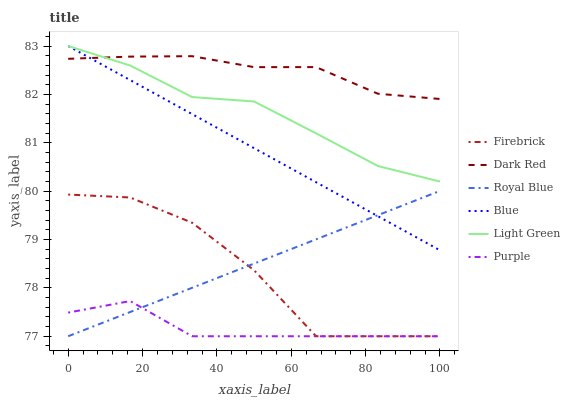Does Dark Red have the minimum area under the curve?
Answer yes or no. No. Does Purple have the maximum area under the curve?
Answer yes or no. No. Is Purple the smoothest?
Answer yes or no. No. Is Purple the roughest?
Answer yes or no. No. Does Dark Red have the lowest value?
Answer yes or no. No. Does Dark Red have the highest value?
Answer yes or no. No. Is Purple less than Dark Red?
Answer yes or no. Yes. Is Dark Red greater than Royal Blue?
Answer yes or no. Yes. Does Purple intersect Dark Red?
Answer yes or no. No. 